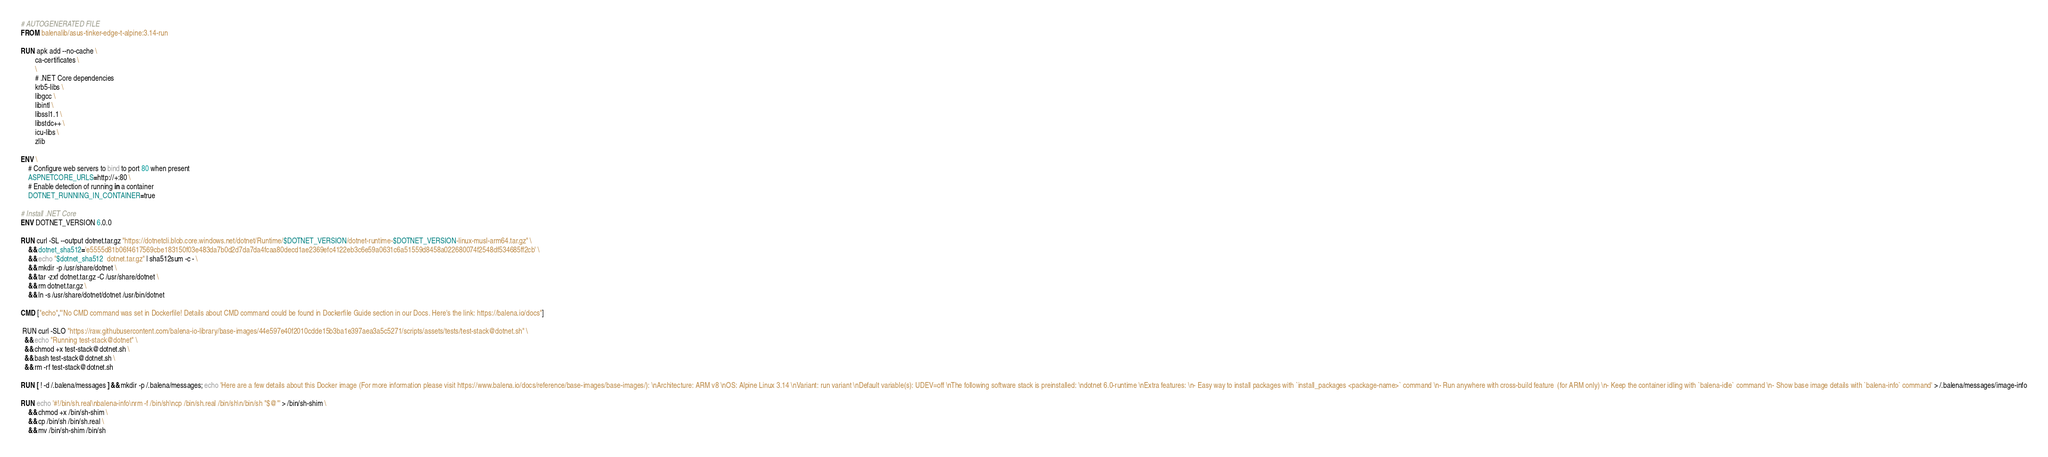Convert code to text. <code><loc_0><loc_0><loc_500><loc_500><_Dockerfile_># AUTOGENERATED FILE
FROM balenalib/asus-tinker-edge-t-alpine:3.14-run

RUN apk add --no-cache \
        ca-certificates \
        \
        # .NET Core dependencies
        krb5-libs \
        libgcc \
        libintl \
        libssl1.1 \
        libstdc++ \
        icu-libs \
        zlib

ENV \
    # Configure web servers to bind to port 80 when present
    ASPNETCORE_URLS=http://+:80 \
    # Enable detection of running in a container
    DOTNET_RUNNING_IN_CONTAINER=true

# Install .NET Core
ENV DOTNET_VERSION 6.0.0

RUN curl -SL --output dotnet.tar.gz "https://dotnetcli.blob.core.windows.net/dotnet/Runtime/$DOTNET_VERSION/dotnet-runtime-$DOTNET_VERSION-linux-musl-arm64.tar.gz" \
    && dotnet_sha512='e5555d81b06f4617569cbe183150f03e483da7b0d2d7da7da4fcaa80decd1ae2369efc4122eb3c6e59a0631c6a51559d8458a022680074f2548df534685ff2cb' \
    && echo "$dotnet_sha512  dotnet.tar.gz" | sha512sum -c - \
    && mkdir -p /usr/share/dotnet \
    && tar -zxf dotnet.tar.gz -C /usr/share/dotnet \
    && rm dotnet.tar.gz \
    && ln -s /usr/share/dotnet/dotnet /usr/bin/dotnet

CMD ["echo","'No CMD command was set in Dockerfile! Details about CMD command could be found in Dockerfile Guide section in our Docs. Here's the link: https://balena.io/docs"]

 RUN curl -SLO "https://raw.githubusercontent.com/balena-io-library/base-images/44e597e40f2010cdde15b3ba1e397aea3a5c5271/scripts/assets/tests/test-stack@dotnet.sh" \
  && echo "Running test-stack@dotnet" \
  && chmod +x test-stack@dotnet.sh \
  && bash test-stack@dotnet.sh \
  && rm -rf test-stack@dotnet.sh 

RUN [ ! -d /.balena/messages ] && mkdir -p /.balena/messages; echo 'Here are a few details about this Docker image (For more information please visit https://www.balena.io/docs/reference/base-images/base-images/): \nArchitecture: ARM v8 \nOS: Alpine Linux 3.14 \nVariant: run variant \nDefault variable(s): UDEV=off \nThe following software stack is preinstalled: \ndotnet 6.0-runtime \nExtra features: \n- Easy way to install packages with `install_packages <package-name>` command \n- Run anywhere with cross-build feature  (for ARM only) \n- Keep the container idling with `balena-idle` command \n- Show base image details with `balena-info` command' > /.balena/messages/image-info

RUN echo '#!/bin/sh.real\nbalena-info\nrm -f /bin/sh\ncp /bin/sh.real /bin/sh\n/bin/sh "$@"' > /bin/sh-shim \
	&& chmod +x /bin/sh-shim \
	&& cp /bin/sh /bin/sh.real \
	&& mv /bin/sh-shim /bin/sh</code> 